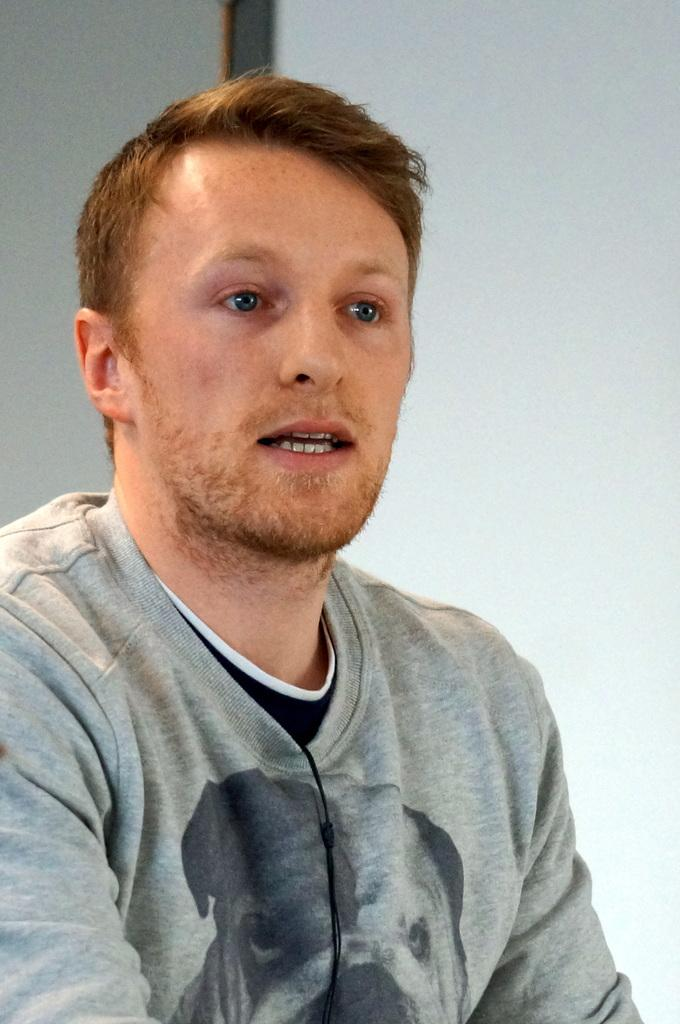Who or what is present in the image? There is a person in the image. What can be seen in the background of the image? There is a wall in the background of the image. What type of crown is the donkey wearing in the image? There is no donkey or crown present in the image; it only features a person and a wall in the background. 